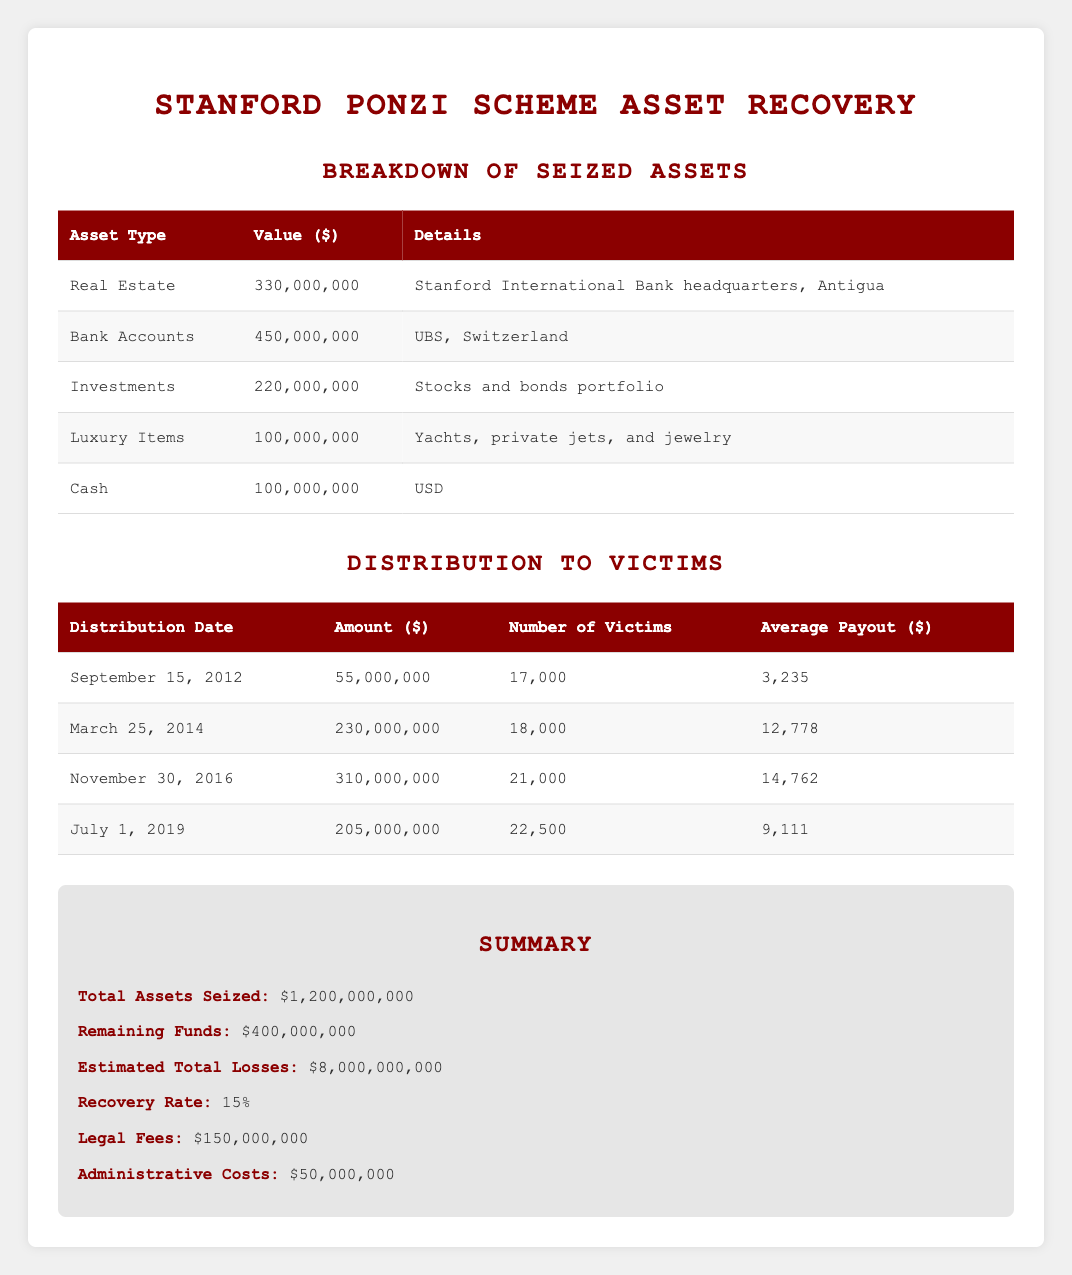What was the total value of seized assets? The total value of seized assets is provided in the summary section of the table. It states that the total assets seized amount to $1,200,000,000.
Answer: 1,200,000,000 What type of asset has the highest value? From the breakdown of seized assets, the asset type with the highest value is "Bank Accounts," valued at $450,000,000.
Answer: Bank Accounts How much was distributed to victims on March 25, 2014? The table lists the distribution amounts by date. On March 25, 2014, the distribution amount was $230,000,000.
Answer: 230,000,000 What percentage of the estimated total losses have been recovered so far? The recovery rate is given as 15%. To find the amount recovered, multiply the estimated total losses ($8,000,000,000) by 0.15, which gives $1,200,000,000 recovered. Since this matches the total seized, the rate is confirmed to be accurate.
Answer: 15% Is the remaining fund greater than the legal fees? The remaining funds amount to $400,000,000, while legal fees total $150,000,000. Since $400,000,000 is greater than $150,000,000, the answer is yes.
Answer: Yes What is the total number of victims who received payouts from the 2016 distribution? The distribution on November 30, 2016, had 21,000 victims receiving payouts. This number is found in the distribution to victims table.
Answer: 21,000 What was the average payout to victims in the last distribution? The last distribution occurred on July 1, 2019, distributing $205,000,000 to 22,500 victims. To find the average payout, divide $205,000,000 by 22,500 which equals approximately $9,111.
Answer: 9,111 What is the total value of luxury items seized? The breakdown lists luxury items valued at $100,000,000 specifically described as yachts, private jets, and jewelry. This information is directly stated in the asset breakdown.
Answer: 100,000,000 How many total victims have received payouts across all distributions? To determine the total number of victims, sum the number of victims from all distributions: 17,000 + 18,000 + 21,000 + 22,500 = 78,500 total victims.
Answer: 78,500 